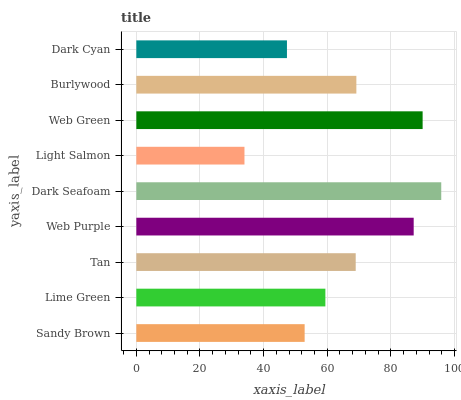Is Light Salmon the minimum?
Answer yes or no. Yes. Is Dark Seafoam the maximum?
Answer yes or no. Yes. Is Lime Green the minimum?
Answer yes or no. No. Is Lime Green the maximum?
Answer yes or no. No. Is Lime Green greater than Sandy Brown?
Answer yes or no. Yes. Is Sandy Brown less than Lime Green?
Answer yes or no. Yes. Is Sandy Brown greater than Lime Green?
Answer yes or no. No. Is Lime Green less than Sandy Brown?
Answer yes or no. No. Is Tan the high median?
Answer yes or no. Yes. Is Tan the low median?
Answer yes or no. Yes. Is Lime Green the high median?
Answer yes or no. No. Is Lime Green the low median?
Answer yes or no. No. 